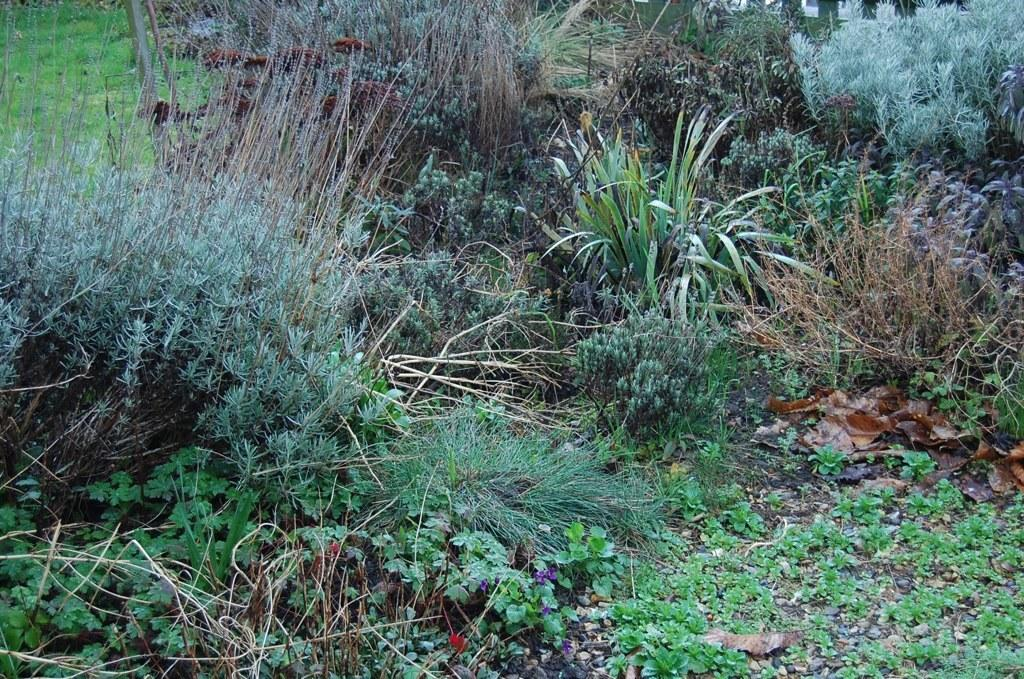What type of plants can be seen on the surface in the image? There are small plant saplings on the surface in the image. What other type of plants are present in the image? There are grass plants in the image. Can you describe the variety of plants in the image? There are different kinds of plants in the image. Where is the pet located in the image? There is no pet present in the image. Can you see a stream flowing through the plants in the image? There is no stream visible in the image. 